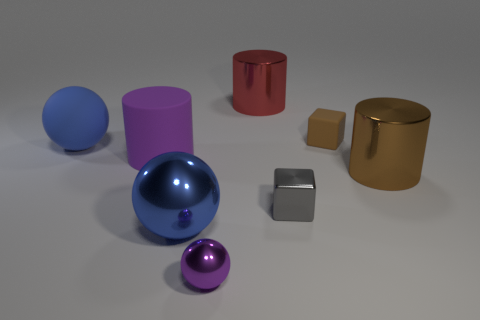There is another shiny object that is the same size as the purple metallic thing; what shape is it?
Ensure brevity in your answer.  Cube. How many other objects are the same color as the tiny shiny sphere?
Provide a short and direct response. 1. What number of things are there?
Your response must be concise. 8. How many balls are both behind the purple ball and in front of the large brown thing?
Make the answer very short. 1. What material is the big red cylinder?
Offer a very short reply. Metal. Is there a matte cube?
Your response must be concise. Yes. What is the color of the sphere behind the metallic cube?
Offer a very short reply. Blue. There is a big metal cylinder that is on the right side of the shiny thing that is behind the matte sphere; how many blue objects are behind it?
Make the answer very short. 1. There is a thing that is both on the left side of the purple metallic object and in front of the brown cylinder; what is its material?
Keep it short and to the point. Metal. Does the small brown block have the same material as the purple object behind the gray metal cube?
Your response must be concise. Yes. 